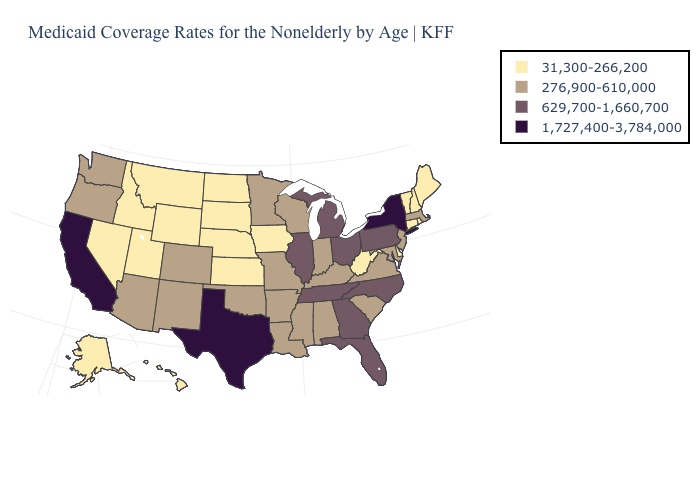Does Maryland have a higher value than Texas?
Answer briefly. No. What is the value of Maryland?
Write a very short answer. 276,900-610,000. Name the states that have a value in the range 1,727,400-3,784,000?
Write a very short answer. California, New York, Texas. Name the states that have a value in the range 276,900-610,000?
Short answer required. Alabama, Arizona, Arkansas, Colorado, Indiana, Kentucky, Louisiana, Maryland, Massachusetts, Minnesota, Mississippi, Missouri, New Jersey, New Mexico, Oklahoma, Oregon, South Carolina, Virginia, Washington, Wisconsin. How many symbols are there in the legend?
Concise answer only. 4. What is the highest value in the South ?
Write a very short answer. 1,727,400-3,784,000. Name the states that have a value in the range 1,727,400-3,784,000?
Concise answer only. California, New York, Texas. What is the highest value in the USA?
Be succinct. 1,727,400-3,784,000. Is the legend a continuous bar?
Quick response, please. No. Which states hav the highest value in the Northeast?
Be succinct. New York. Does the map have missing data?
Be succinct. No. What is the value of South Carolina?
Give a very brief answer. 276,900-610,000. Name the states that have a value in the range 629,700-1,660,700?
Give a very brief answer. Florida, Georgia, Illinois, Michigan, North Carolina, Ohio, Pennsylvania, Tennessee. Name the states that have a value in the range 629,700-1,660,700?
Concise answer only. Florida, Georgia, Illinois, Michigan, North Carolina, Ohio, Pennsylvania, Tennessee. Among the states that border Tennessee , does Alabama have the highest value?
Short answer required. No. 